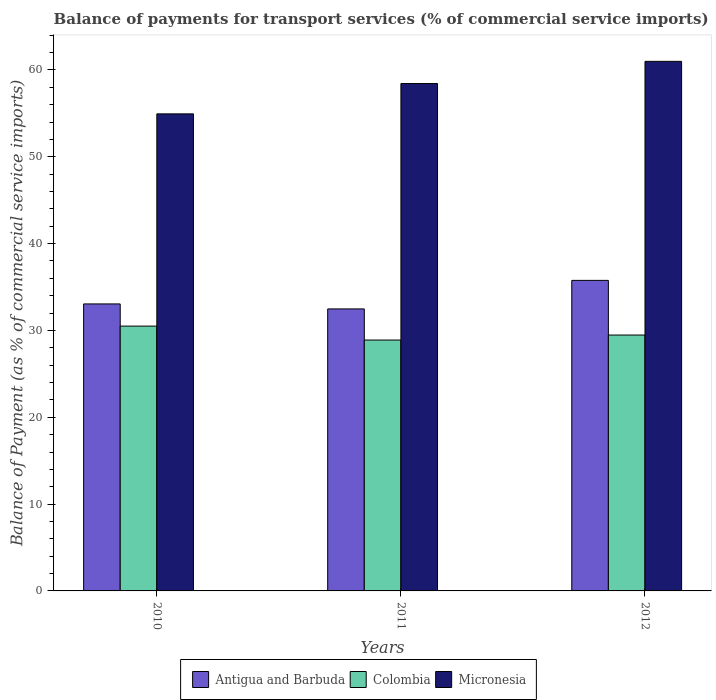How many different coloured bars are there?
Give a very brief answer. 3. How many groups of bars are there?
Ensure brevity in your answer.  3. Are the number of bars on each tick of the X-axis equal?
Provide a succinct answer. Yes. How many bars are there on the 2nd tick from the left?
Your answer should be very brief. 3. How many bars are there on the 2nd tick from the right?
Your answer should be compact. 3. What is the label of the 2nd group of bars from the left?
Your answer should be very brief. 2011. In how many cases, is the number of bars for a given year not equal to the number of legend labels?
Provide a short and direct response. 0. What is the balance of payments for transport services in Colombia in 2011?
Give a very brief answer. 28.9. Across all years, what is the maximum balance of payments for transport services in Colombia?
Offer a terse response. 30.5. Across all years, what is the minimum balance of payments for transport services in Colombia?
Provide a succinct answer. 28.9. In which year was the balance of payments for transport services in Micronesia minimum?
Your response must be concise. 2010. What is the total balance of payments for transport services in Colombia in the graph?
Provide a short and direct response. 88.87. What is the difference between the balance of payments for transport services in Colombia in 2011 and that in 2012?
Keep it short and to the point. -0.58. What is the difference between the balance of payments for transport services in Micronesia in 2010 and the balance of payments for transport services in Antigua and Barbuda in 2012?
Give a very brief answer. 19.18. What is the average balance of payments for transport services in Antigua and Barbuda per year?
Provide a succinct answer. 33.77. In the year 2010, what is the difference between the balance of payments for transport services in Micronesia and balance of payments for transport services in Colombia?
Your response must be concise. 24.44. What is the ratio of the balance of payments for transport services in Micronesia in 2010 to that in 2011?
Give a very brief answer. 0.94. Is the balance of payments for transport services in Antigua and Barbuda in 2010 less than that in 2011?
Provide a short and direct response. No. What is the difference between the highest and the second highest balance of payments for transport services in Antigua and Barbuda?
Ensure brevity in your answer.  2.71. What is the difference between the highest and the lowest balance of payments for transport services in Micronesia?
Offer a terse response. 6.05. In how many years, is the balance of payments for transport services in Antigua and Barbuda greater than the average balance of payments for transport services in Antigua and Barbuda taken over all years?
Ensure brevity in your answer.  1. What does the 3rd bar from the right in 2011 represents?
Offer a terse response. Antigua and Barbuda. Is it the case that in every year, the sum of the balance of payments for transport services in Antigua and Barbuda and balance of payments for transport services in Colombia is greater than the balance of payments for transport services in Micronesia?
Your answer should be compact. Yes. How many years are there in the graph?
Your response must be concise. 3. Does the graph contain any zero values?
Offer a very short reply. No. Does the graph contain grids?
Your answer should be very brief. No. Where does the legend appear in the graph?
Make the answer very short. Bottom center. How many legend labels are there?
Your answer should be compact. 3. How are the legend labels stacked?
Ensure brevity in your answer.  Horizontal. What is the title of the graph?
Ensure brevity in your answer.  Balance of payments for transport services (% of commercial service imports). What is the label or title of the X-axis?
Your answer should be very brief. Years. What is the label or title of the Y-axis?
Keep it short and to the point. Balance of Payment (as % of commercial service imports). What is the Balance of Payment (as % of commercial service imports) of Antigua and Barbuda in 2010?
Your response must be concise. 33.05. What is the Balance of Payment (as % of commercial service imports) of Colombia in 2010?
Make the answer very short. 30.5. What is the Balance of Payment (as % of commercial service imports) in Micronesia in 2010?
Your answer should be compact. 54.94. What is the Balance of Payment (as % of commercial service imports) in Antigua and Barbuda in 2011?
Your response must be concise. 32.48. What is the Balance of Payment (as % of commercial service imports) in Colombia in 2011?
Offer a terse response. 28.9. What is the Balance of Payment (as % of commercial service imports) of Micronesia in 2011?
Give a very brief answer. 58.44. What is the Balance of Payment (as % of commercial service imports) of Antigua and Barbuda in 2012?
Offer a terse response. 35.77. What is the Balance of Payment (as % of commercial service imports) of Colombia in 2012?
Make the answer very short. 29.47. What is the Balance of Payment (as % of commercial service imports) in Micronesia in 2012?
Make the answer very short. 60.99. Across all years, what is the maximum Balance of Payment (as % of commercial service imports) of Antigua and Barbuda?
Offer a very short reply. 35.77. Across all years, what is the maximum Balance of Payment (as % of commercial service imports) in Colombia?
Your answer should be very brief. 30.5. Across all years, what is the maximum Balance of Payment (as % of commercial service imports) in Micronesia?
Keep it short and to the point. 60.99. Across all years, what is the minimum Balance of Payment (as % of commercial service imports) of Antigua and Barbuda?
Your answer should be very brief. 32.48. Across all years, what is the minimum Balance of Payment (as % of commercial service imports) of Colombia?
Offer a terse response. 28.9. Across all years, what is the minimum Balance of Payment (as % of commercial service imports) of Micronesia?
Give a very brief answer. 54.94. What is the total Balance of Payment (as % of commercial service imports) of Antigua and Barbuda in the graph?
Offer a very short reply. 101.3. What is the total Balance of Payment (as % of commercial service imports) of Colombia in the graph?
Your answer should be very brief. 88.87. What is the total Balance of Payment (as % of commercial service imports) of Micronesia in the graph?
Your response must be concise. 174.38. What is the difference between the Balance of Payment (as % of commercial service imports) in Antigua and Barbuda in 2010 and that in 2011?
Make the answer very short. 0.57. What is the difference between the Balance of Payment (as % of commercial service imports) of Colombia in 2010 and that in 2011?
Ensure brevity in your answer.  1.6. What is the difference between the Balance of Payment (as % of commercial service imports) of Micronesia in 2010 and that in 2011?
Keep it short and to the point. -3.49. What is the difference between the Balance of Payment (as % of commercial service imports) in Antigua and Barbuda in 2010 and that in 2012?
Make the answer very short. -2.71. What is the difference between the Balance of Payment (as % of commercial service imports) of Colombia in 2010 and that in 2012?
Ensure brevity in your answer.  1.03. What is the difference between the Balance of Payment (as % of commercial service imports) of Micronesia in 2010 and that in 2012?
Give a very brief answer. -6.05. What is the difference between the Balance of Payment (as % of commercial service imports) of Antigua and Barbuda in 2011 and that in 2012?
Your response must be concise. -3.29. What is the difference between the Balance of Payment (as % of commercial service imports) of Colombia in 2011 and that in 2012?
Provide a succinct answer. -0.58. What is the difference between the Balance of Payment (as % of commercial service imports) in Micronesia in 2011 and that in 2012?
Your answer should be very brief. -2.56. What is the difference between the Balance of Payment (as % of commercial service imports) in Antigua and Barbuda in 2010 and the Balance of Payment (as % of commercial service imports) in Colombia in 2011?
Offer a very short reply. 4.16. What is the difference between the Balance of Payment (as % of commercial service imports) in Antigua and Barbuda in 2010 and the Balance of Payment (as % of commercial service imports) in Micronesia in 2011?
Give a very brief answer. -25.38. What is the difference between the Balance of Payment (as % of commercial service imports) in Colombia in 2010 and the Balance of Payment (as % of commercial service imports) in Micronesia in 2011?
Ensure brevity in your answer.  -27.94. What is the difference between the Balance of Payment (as % of commercial service imports) of Antigua and Barbuda in 2010 and the Balance of Payment (as % of commercial service imports) of Colombia in 2012?
Keep it short and to the point. 3.58. What is the difference between the Balance of Payment (as % of commercial service imports) of Antigua and Barbuda in 2010 and the Balance of Payment (as % of commercial service imports) of Micronesia in 2012?
Offer a very short reply. -27.94. What is the difference between the Balance of Payment (as % of commercial service imports) of Colombia in 2010 and the Balance of Payment (as % of commercial service imports) of Micronesia in 2012?
Your answer should be compact. -30.49. What is the difference between the Balance of Payment (as % of commercial service imports) in Antigua and Barbuda in 2011 and the Balance of Payment (as % of commercial service imports) in Colombia in 2012?
Your answer should be compact. 3.01. What is the difference between the Balance of Payment (as % of commercial service imports) of Antigua and Barbuda in 2011 and the Balance of Payment (as % of commercial service imports) of Micronesia in 2012?
Provide a short and direct response. -28.51. What is the difference between the Balance of Payment (as % of commercial service imports) of Colombia in 2011 and the Balance of Payment (as % of commercial service imports) of Micronesia in 2012?
Ensure brevity in your answer.  -32.1. What is the average Balance of Payment (as % of commercial service imports) of Antigua and Barbuda per year?
Keep it short and to the point. 33.77. What is the average Balance of Payment (as % of commercial service imports) of Colombia per year?
Provide a short and direct response. 29.62. What is the average Balance of Payment (as % of commercial service imports) of Micronesia per year?
Your response must be concise. 58.13. In the year 2010, what is the difference between the Balance of Payment (as % of commercial service imports) in Antigua and Barbuda and Balance of Payment (as % of commercial service imports) in Colombia?
Provide a short and direct response. 2.55. In the year 2010, what is the difference between the Balance of Payment (as % of commercial service imports) of Antigua and Barbuda and Balance of Payment (as % of commercial service imports) of Micronesia?
Give a very brief answer. -21.89. In the year 2010, what is the difference between the Balance of Payment (as % of commercial service imports) of Colombia and Balance of Payment (as % of commercial service imports) of Micronesia?
Keep it short and to the point. -24.44. In the year 2011, what is the difference between the Balance of Payment (as % of commercial service imports) of Antigua and Barbuda and Balance of Payment (as % of commercial service imports) of Colombia?
Give a very brief answer. 3.58. In the year 2011, what is the difference between the Balance of Payment (as % of commercial service imports) of Antigua and Barbuda and Balance of Payment (as % of commercial service imports) of Micronesia?
Your answer should be compact. -25.96. In the year 2011, what is the difference between the Balance of Payment (as % of commercial service imports) in Colombia and Balance of Payment (as % of commercial service imports) in Micronesia?
Offer a terse response. -29.54. In the year 2012, what is the difference between the Balance of Payment (as % of commercial service imports) in Antigua and Barbuda and Balance of Payment (as % of commercial service imports) in Colombia?
Your answer should be compact. 6.29. In the year 2012, what is the difference between the Balance of Payment (as % of commercial service imports) in Antigua and Barbuda and Balance of Payment (as % of commercial service imports) in Micronesia?
Offer a very short reply. -25.23. In the year 2012, what is the difference between the Balance of Payment (as % of commercial service imports) of Colombia and Balance of Payment (as % of commercial service imports) of Micronesia?
Offer a terse response. -31.52. What is the ratio of the Balance of Payment (as % of commercial service imports) in Antigua and Barbuda in 2010 to that in 2011?
Provide a succinct answer. 1.02. What is the ratio of the Balance of Payment (as % of commercial service imports) of Colombia in 2010 to that in 2011?
Offer a terse response. 1.06. What is the ratio of the Balance of Payment (as % of commercial service imports) in Micronesia in 2010 to that in 2011?
Offer a terse response. 0.94. What is the ratio of the Balance of Payment (as % of commercial service imports) of Antigua and Barbuda in 2010 to that in 2012?
Give a very brief answer. 0.92. What is the ratio of the Balance of Payment (as % of commercial service imports) in Colombia in 2010 to that in 2012?
Your answer should be compact. 1.03. What is the ratio of the Balance of Payment (as % of commercial service imports) in Micronesia in 2010 to that in 2012?
Provide a succinct answer. 0.9. What is the ratio of the Balance of Payment (as % of commercial service imports) in Antigua and Barbuda in 2011 to that in 2012?
Your response must be concise. 0.91. What is the ratio of the Balance of Payment (as % of commercial service imports) of Colombia in 2011 to that in 2012?
Offer a terse response. 0.98. What is the ratio of the Balance of Payment (as % of commercial service imports) in Micronesia in 2011 to that in 2012?
Your response must be concise. 0.96. What is the difference between the highest and the second highest Balance of Payment (as % of commercial service imports) in Antigua and Barbuda?
Make the answer very short. 2.71. What is the difference between the highest and the second highest Balance of Payment (as % of commercial service imports) of Colombia?
Offer a terse response. 1.03. What is the difference between the highest and the second highest Balance of Payment (as % of commercial service imports) of Micronesia?
Your response must be concise. 2.56. What is the difference between the highest and the lowest Balance of Payment (as % of commercial service imports) of Antigua and Barbuda?
Your answer should be compact. 3.29. What is the difference between the highest and the lowest Balance of Payment (as % of commercial service imports) in Colombia?
Provide a short and direct response. 1.6. What is the difference between the highest and the lowest Balance of Payment (as % of commercial service imports) in Micronesia?
Make the answer very short. 6.05. 